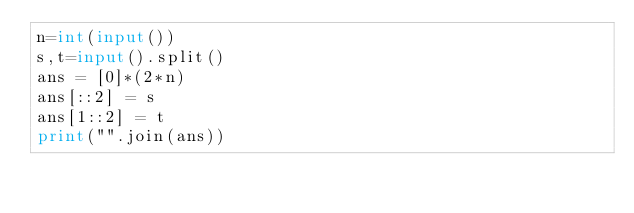Convert code to text. <code><loc_0><loc_0><loc_500><loc_500><_Python_>n=int(input())
s,t=input().split()
ans = [0]*(2*n)
ans[::2] = s
ans[1::2] = t
print("".join(ans))</code> 